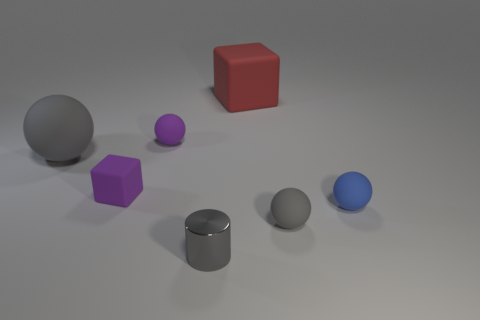Is there anything else that is the same material as the gray cylinder?
Offer a very short reply. No. There is another block that is the same material as the red cube; what color is it?
Give a very brief answer. Purple. Do the blue object and the gray object that is to the right of the big red matte block have the same shape?
Offer a very short reply. Yes. There is a shiny cylinder; are there any shiny things in front of it?
Ensure brevity in your answer.  No. There is a cylinder that is the same color as the big ball; what is its material?
Your response must be concise. Metal. Do the metal thing and the gray matte thing to the right of the big gray sphere have the same size?
Your answer should be compact. Yes. Are there any balls that have the same color as the small matte cube?
Make the answer very short. Yes. Is there a tiny gray rubber object of the same shape as the big gray thing?
Keep it short and to the point. Yes. What shape is the gray object that is both on the left side of the large matte block and in front of the blue matte thing?
Provide a short and direct response. Cylinder. How many small purple blocks are made of the same material as the large sphere?
Provide a short and direct response. 1. 